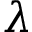<formula> <loc_0><loc_0><loc_500><loc_500>\lambda</formula> 